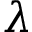<formula> <loc_0><loc_0><loc_500><loc_500>\lambda</formula> 